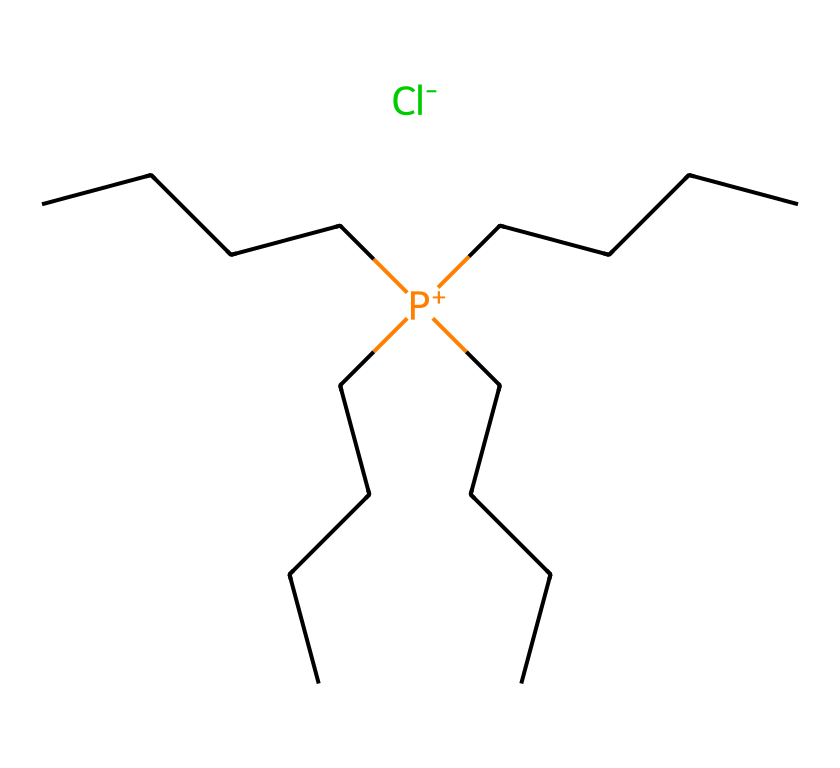What is the molecular cation present in this ionic liquid? The cation is represented by [P+](CCCC)(CCCC)(CCCC)CCCC, indicating that it contains a phosphonium cation structure with four long alkyl chains attached.
Answer: phosphonium How many carbon atoms are in the structure? Each CCCCC represents a five-carbon alkyl chain, and there are four such chains. Therefore, 4 chains × 4 carbon atoms = 20 carbon atoms total.
Answer: 20 What type of bond is predominantly present in this ionic liquid? The presence of a phosphonium cation and chloride anion indicates the presence of ionic bonds, as ionic liquids are characterized by their ion-separated structure.
Answer: ionic bond What is the anion associated with this ionic liquid? The anion is represented by [Cl-], indicating that it is a chloride ion.
Answer: chloride Which feature of this ionic liquid suggests it's suitable for extracting medicinal plant compounds? The long alkyl chains in the phosphonium cation provide hydrophobic characteristics, which enhance solubility in organic compounds and make it effective for extraction applications.
Answer: long alkyl chains What is the expected phase of this ionic liquid at room temperature? Ionic liquids typically have low vapor pressure and remain liquid at a wide range of temperatures, implying that it would likely be in the liquid phase at room temperature.
Answer: liquid 